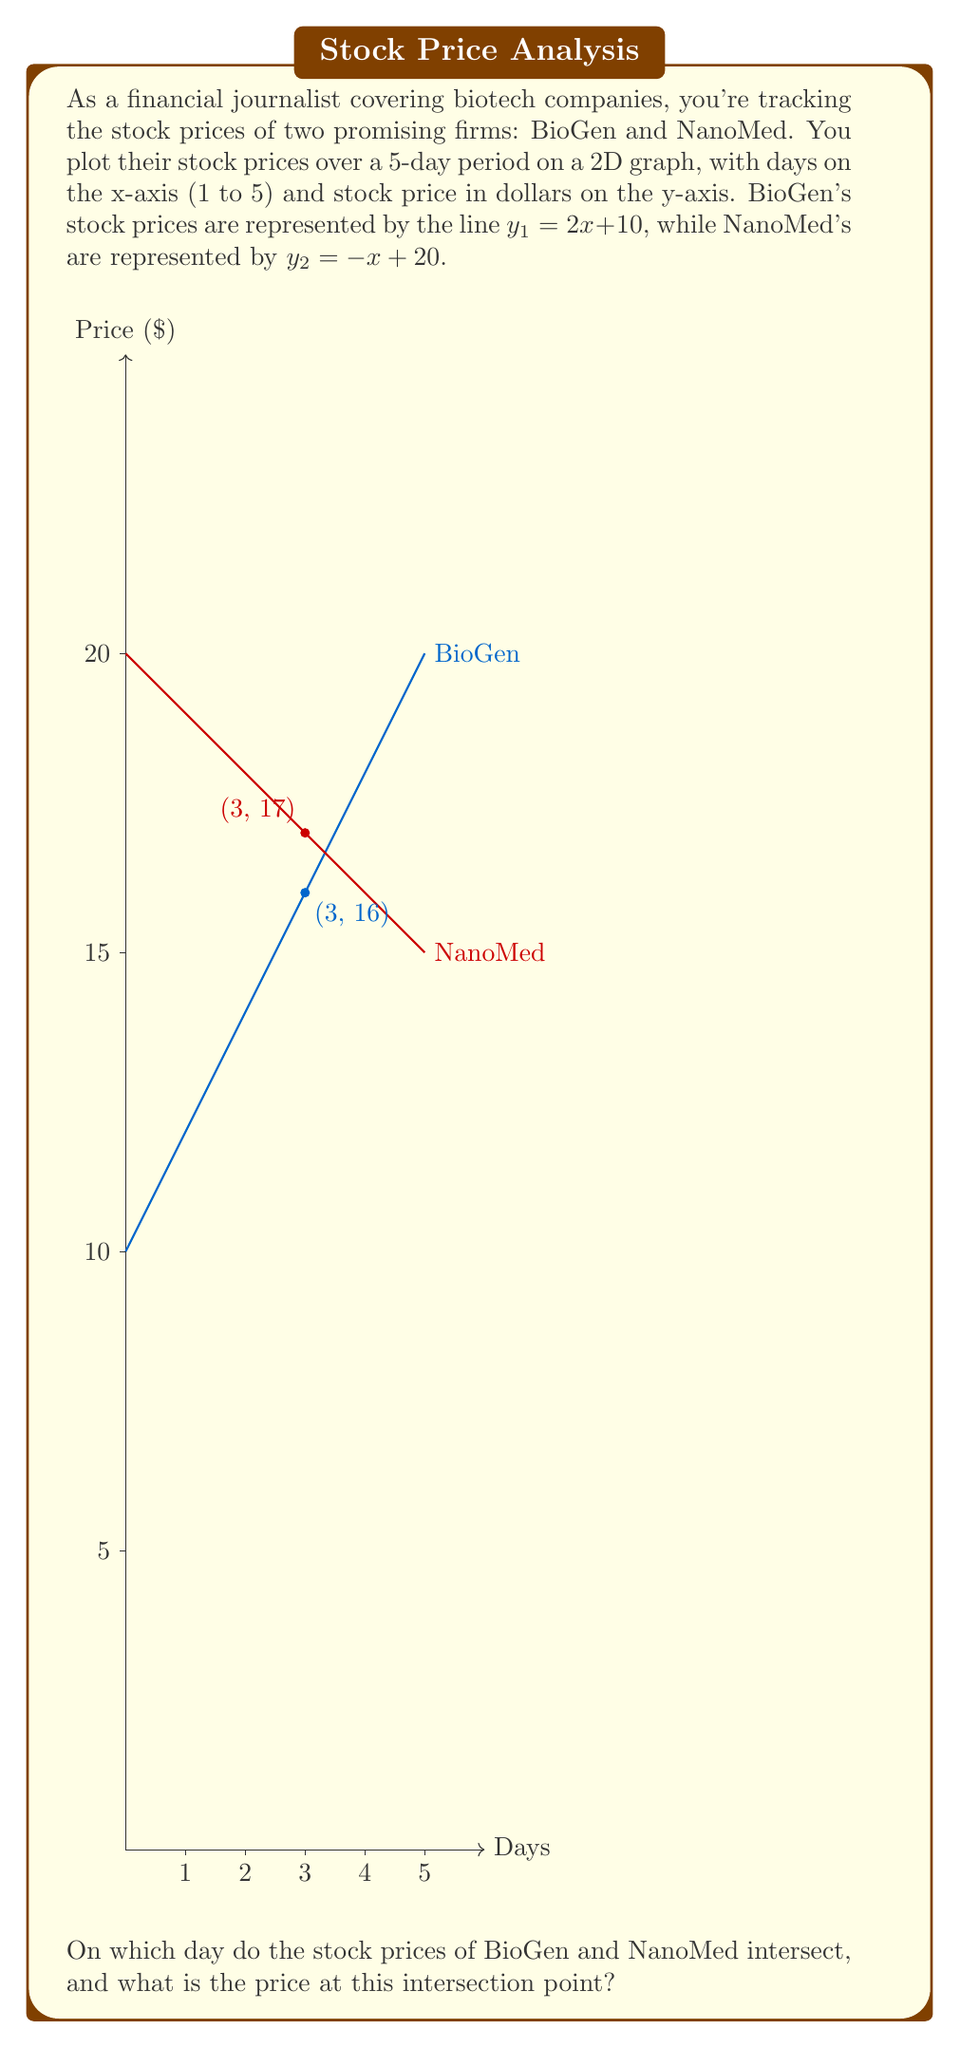What is the answer to this math problem? To find the intersection point of the two lines, we need to solve the system of equations:

$$\begin{cases}
y_1 = 2x + 10 \\
y_2 = -x + 20
\end{cases}$$

At the intersection point, $y_1 = y_2$, so we can set the equations equal to each other:

$$2x + 10 = -x + 20$$

Now, let's solve for x:

1) Add x to both sides:
   $$3x + 10 = 20$$

2) Subtract 10 from both sides:
   $$3x = 10$$

3) Divide both sides by 3:
   $$x = \frac{10}{3} \approx 3.33$$

This x-value represents the day of intersection (between day 3 and 4).

To find the price at this point, we can substitute this x-value into either of the original equations. Let's use BioGen's equation:

$$y = 2(\frac{10}{3}) + 10 = \frac{20}{3} + 10 = \frac{20}{3} + \frac{30}{3} = \frac{50}{3} \approx 16.67$$

Therefore, the stock prices intersect on day $\frac{10}{3}$ (approximately 3.33 days) at a price of $\frac{50}{3}$ dollars (approximately $16.67).
Answer: Day $\frac{10}{3}$ at $\frac{50}{3}$ dollars 